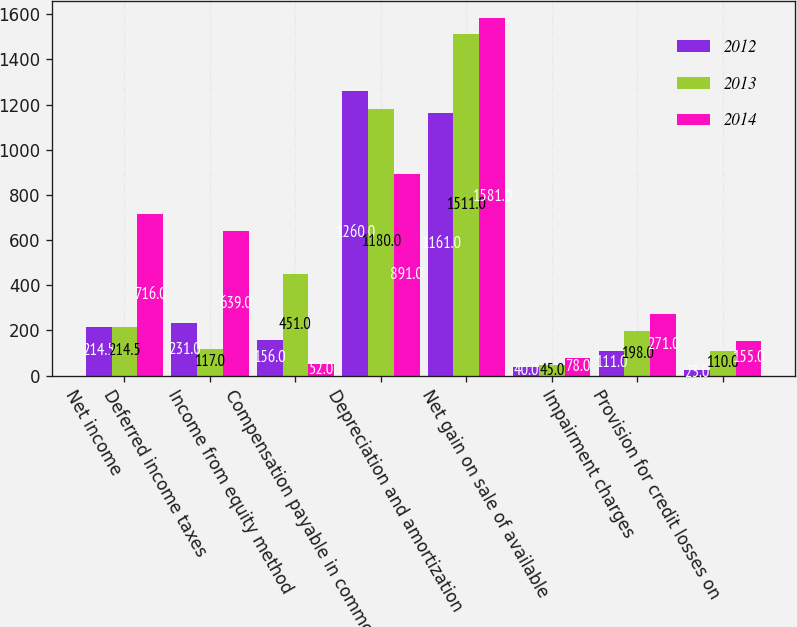Convert chart to OTSL. <chart><loc_0><loc_0><loc_500><loc_500><stacked_bar_chart><ecel><fcel>Net income<fcel>Deferred income taxes<fcel>Income from equity method<fcel>Compensation payable in common<fcel>Depreciation and amortization<fcel>Net gain on sale of available<fcel>Impairment charges<fcel>Provision for credit losses on<nl><fcel>2012<fcel>214.5<fcel>231<fcel>156<fcel>1260<fcel>1161<fcel>40<fcel>111<fcel>23<nl><fcel>2013<fcel>214.5<fcel>117<fcel>451<fcel>1180<fcel>1511<fcel>45<fcel>198<fcel>110<nl><fcel>2014<fcel>716<fcel>639<fcel>52<fcel>891<fcel>1581<fcel>78<fcel>271<fcel>155<nl></chart> 